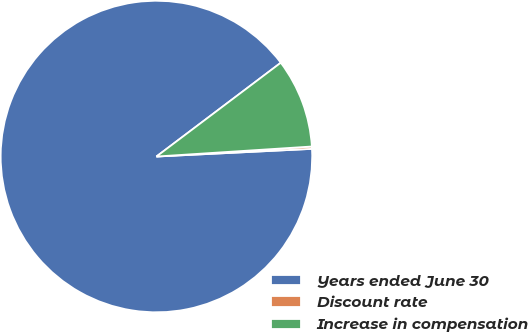<chart> <loc_0><loc_0><loc_500><loc_500><pie_chart><fcel>Years ended June 30<fcel>Discount rate<fcel>Increase in compensation<nl><fcel>90.5%<fcel>0.24%<fcel>9.26%<nl></chart> 